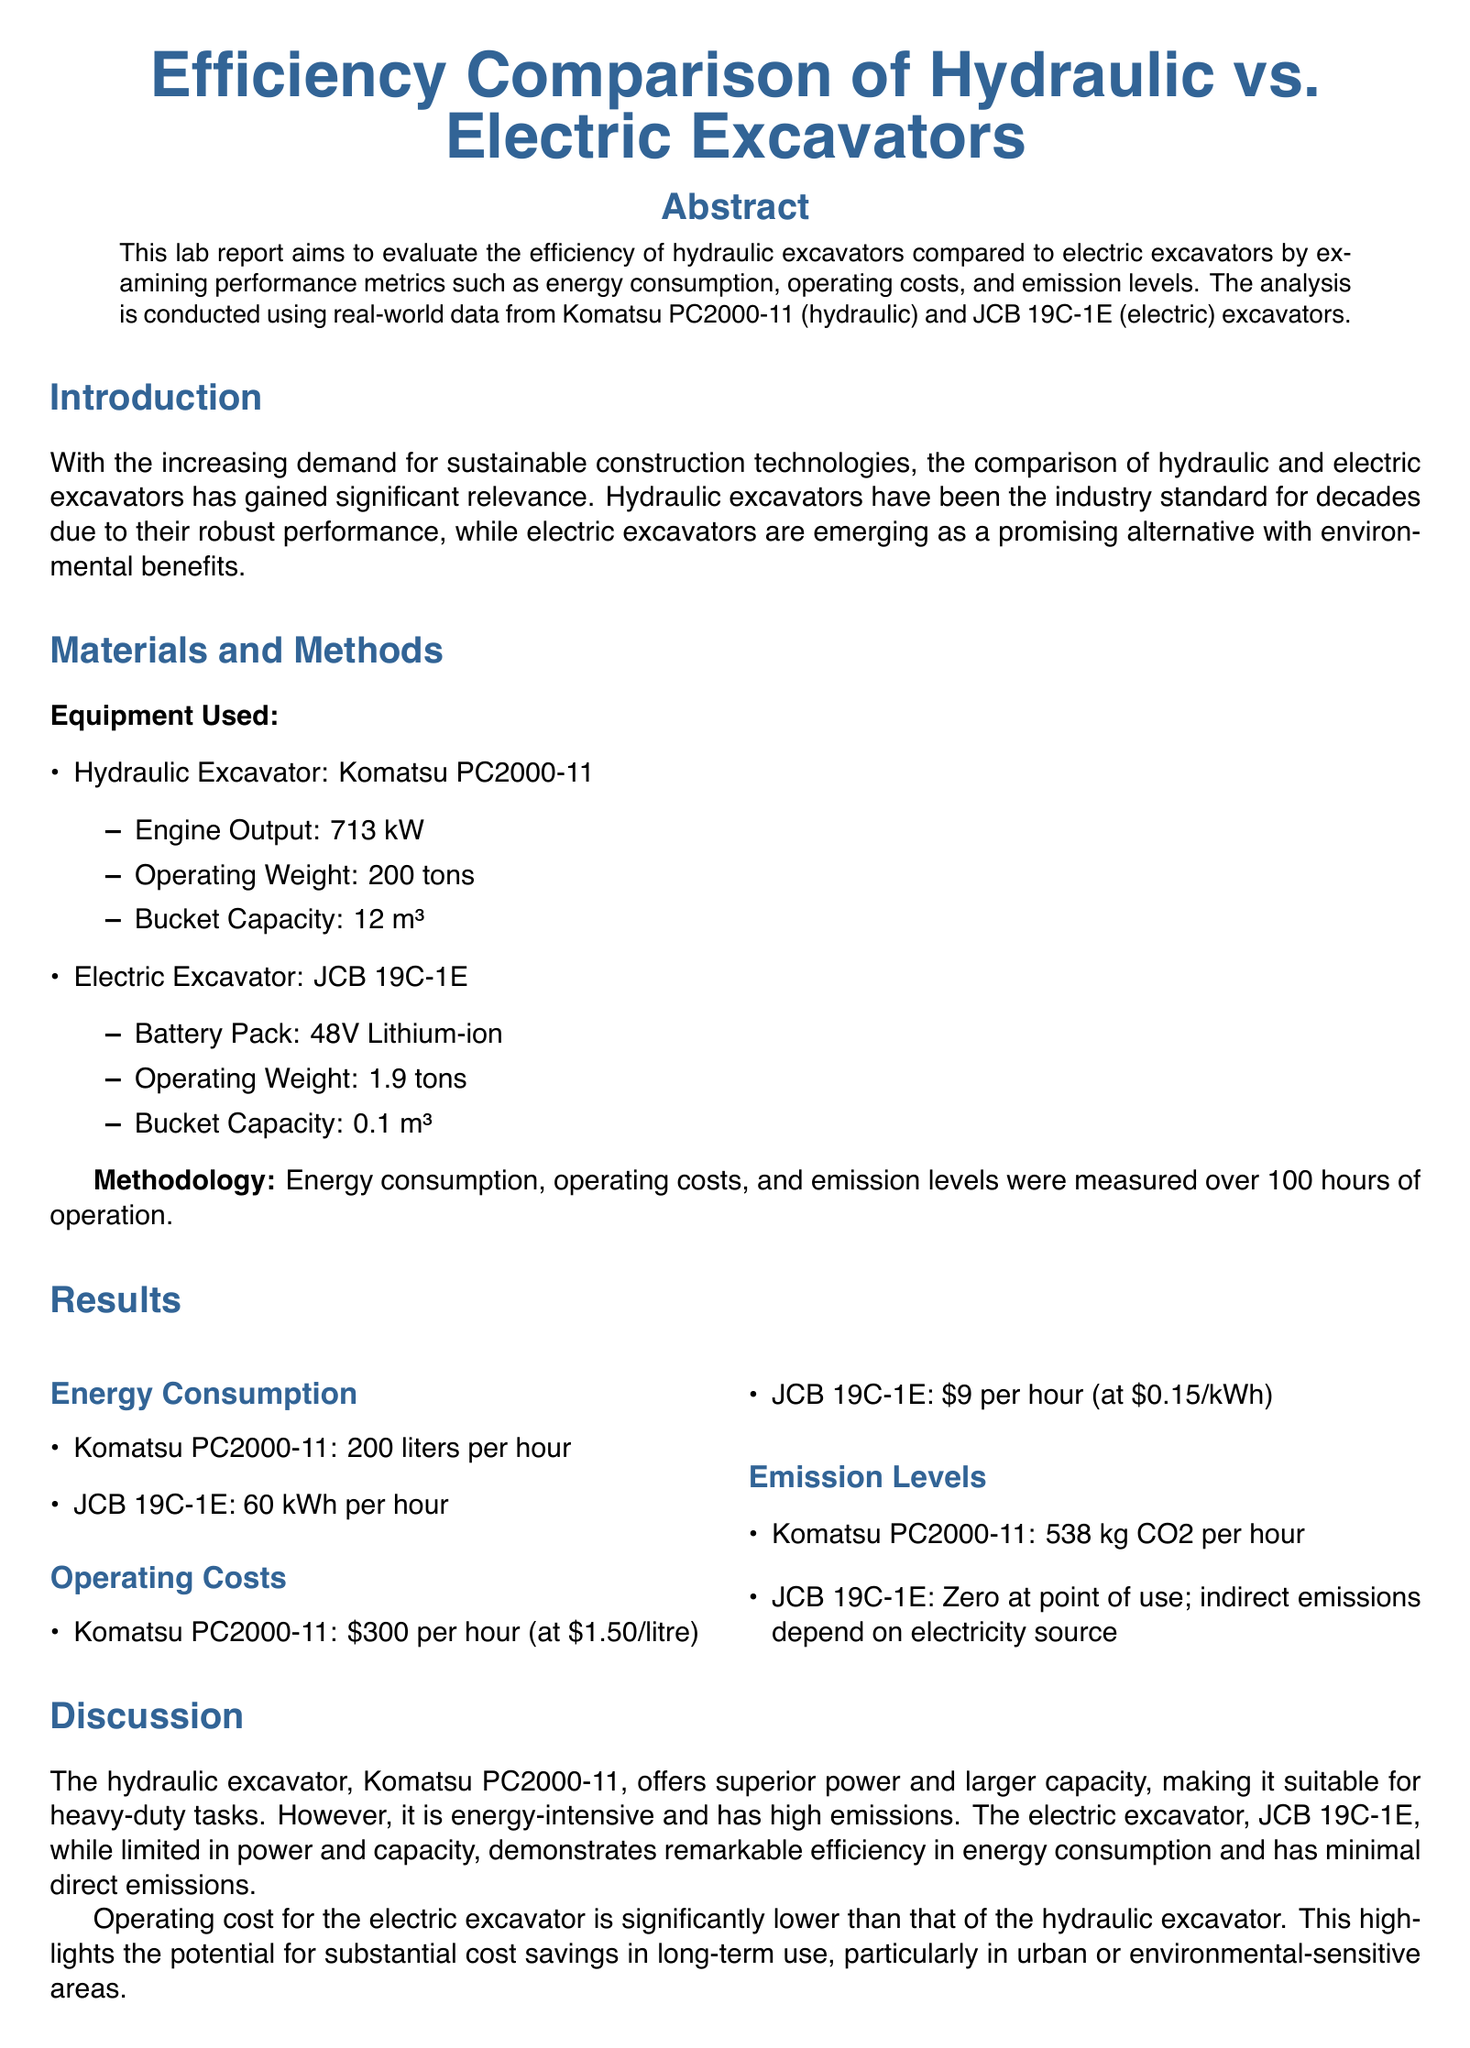what is the engine output of the hydraulic excavator? The engine output of the hydraulic excavator, Komatsu PC2000-11, is explicitly stated in the document.
Answer: 713 kW what is the operating weight of the electric excavator? The operating weight for the electric excavator, JCB 19C-1E, is mentioned under its specifications.
Answer: 1.9 tons how much energy does the electric excavator consume per hour? The energy consumption of the electric excavator is detailed in the results section.
Answer: 60 kWh per hour what is the operating cost of the hydraulic excavator? The operating cost for the hydraulic excavator is provided in the results section.
Answer: $300 per hour which excavator has lower operating costs? The discussion section compares the operating costs of both excavators, highlighting the difference.
Answer: Electric excavator what is the emission level of the hydraulic excavator? The emission levels are provided in the results section, indicating the amount for the hydraulic excavator.
Answer: 538 kg CO2 per hour how many hours was the performance measured? The methodology section states the duration for which the performance metrics were recorded.
Answer: 100 hours what is the bucket capacity of the hydraulic excavator? The bucket capacity for the hydraulic excavator is listed in its specifications.
Answer: 12 m³ what is the conclusion regarding electric excavators? The conclusion summarizes the findings about electric excavators in comparison to hydraulic models.
Answer: More efficient energy consumption and lower operating costs 